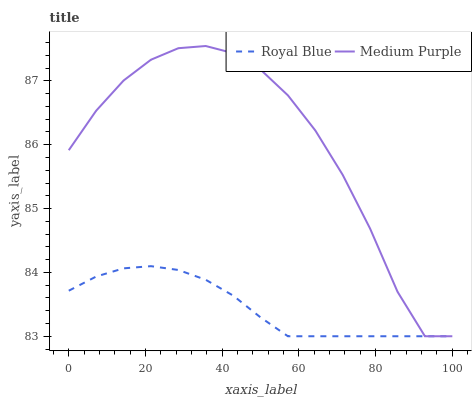Does Royal Blue have the minimum area under the curve?
Answer yes or no. Yes. Does Medium Purple have the maximum area under the curve?
Answer yes or no. Yes. Does Royal Blue have the maximum area under the curve?
Answer yes or no. No. Is Royal Blue the smoothest?
Answer yes or no. Yes. Is Medium Purple the roughest?
Answer yes or no. Yes. Is Royal Blue the roughest?
Answer yes or no. No. Does Medium Purple have the highest value?
Answer yes or no. Yes. Does Royal Blue have the highest value?
Answer yes or no. No. 